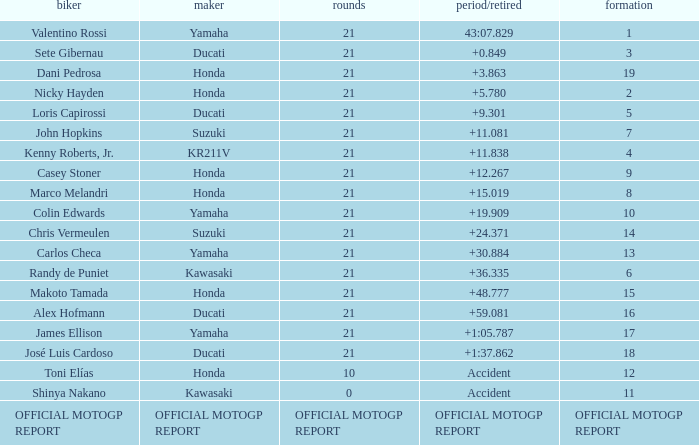Which rider had a time/retired od +19.909? Colin Edwards. 